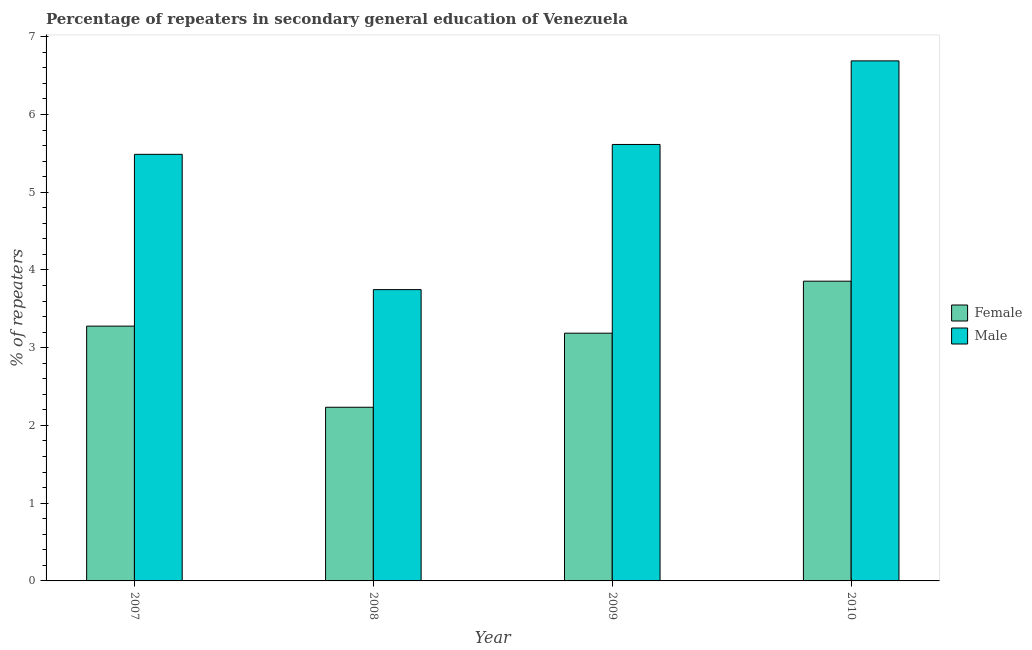How many groups of bars are there?
Offer a very short reply. 4. Are the number of bars per tick equal to the number of legend labels?
Offer a very short reply. Yes. Are the number of bars on each tick of the X-axis equal?
Your answer should be very brief. Yes. What is the label of the 2nd group of bars from the left?
Your answer should be very brief. 2008. In how many cases, is the number of bars for a given year not equal to the number of legend labels?
Keep it short and to the point. 0. What is the percentage of female repeaters in 2009?
Your answer should be very brief. 3.19. Across all years, what is the maximum percentage of male repeaters?
Ensure brevity in your answer.  6.69. Across all years, what is the minimum percentage of female repeaters?
Your answer should be compact. 2.23. In which year was the percentage of male repeaters maximum?
Your response must be concise. 2010. In which year was the percentage of female repeaters minimum?
Offer a very short reply. 2008. What is the total percentage of female repeaters in the graph?
Provide a short and direct response. 12.55. What is the difference between the percentage of female repeaters in 2009 and that in 2010?
Your answer should be compact. -0.67. What is the difference between the percentage of male repeaters in 2009 and the percentage of female repeaters in 2008?
Offer a very short reply. 1.87. What is the average percentage of male repeaters per year?
Your response must be concise. 5.38. What is the ratio of the percentage of male repeaters in 2007 to that in 2010?
Offer a very short reply. 0.82. Is the percentage of male repeaters in 2008 less than that in 2009?
Provide a short and direct response. Yes. What is the difference between the highest and the second highest percentage of female repeaters?
Give a very brief answer. 0.58. What is the difference between the highest and the lowest percentage of female repeaters?
Your response must be concise. 1.62. Is the sum of the percentage of female repeaters in 2007 and 2009 greater than the maximum percentage of male repeaters across all years?
Make the answer very short. Yes. What does the 2nd bar from the left in 2007 represents?
Give a very brief answer. Male. What does the 1st bar from the right in 2007 represents?
Offer a very short reply. Male. How many years are there in the graph?
Your answer should be compact. 4. What is the difference between two consecutive major ticks on the Y-axis?
Offer a very short reply. 1. Are the values on the major ticks of Y-axis written in scientific E-notation?
Provide a short and direct response. No. Does the graph contain grids?
Provide a succinct answer. No. Where does the legend appear in the graph?
Ensure brevity in your answer.  Center right. How many legend labels are there?
Provide a short and direct response. 2. What is the title of the graph?
Offer a terse response. Percentage of repeaters in secondary general education of Venezuela. What is the label or title of the Y-axis?
Keep it short and to the point. % of repeaters. What is the % of repeaters in Female in 2007?
Offer a terse response. 3.28. What is the % of repeaters in Male in 2007?
Your answer should be compact. 5.49. What is the % of repeaters in Female in 2008?
Offer a terse response. 2.23. What is the % of repeaters in Male in 2008?
Give a very brief answer. 3.75. What is the % of repeaters in Female in 2009?
Your answer should be compact. 3.19. What is the % of repeaters of Male in 2009?
Offer a very short reply. 5.61. What is the % of repeaters in Female in 2010?
Provide a short and direct response. 3.86. What is the % of repeaters of Male in 2010?
Your answer should be compact. 6.69. Across all years, what is the maximum % of repeaters in Female?
Offer a very short reply. 3.86. Across all years, what is the maximum % of repeaters in Male?
Offer a terse response. 6.69. Across all years, what is the minimum % of repeaters of Female?
Make the answer very short. 2.23. Across all years, what is the minimum % of repeaters in Male?
Keep it short and to the point. 3.75. What is the total % of repeaters of Female in the graph?
Your answer should be compact. 12.55. What is the total % of repeaters in Male in the graph?
Your answer should be very brief. 21.54. What is the difference between the % of repeaters in Female in 2007 and that in 2008?
Ensure brevity in your answer.  1.04. What is the difference between the % of repeaters in Male in 2007 and that in 2008?
Provide a short and direct response. 1.74. What is the difference between the % of repeaters of Female in 2007 and that in 2009?
Keep it short and to the point. 0.09. What is the difference between the % of repeaters in Male in 2007 and that in 2009?
Your answer should be very brief. -0.13. What is the difference between the % of repeaters of Female in 2007 and that in 2010?
Give a very brief answer. -0.58. What is the difference between the % of repeaters of Male in 2007 and that in 2010?
Your answer should be very brief. -1.2. What is the difference between the % of repeaters of Female in 2008 and that in 2009?
Provide a succinct answer. -0.95. What is the difference between the % of repeaters in Male in 2008 and that in 2009?
Give a very brief answer. -1.87. What is the difference between the % of repeaters of Female in 2008 and that in 2010?
Offer a very short reply. -1.62. What is the difference between the % of repeaters in Male in 2008 and that in 2010?
Keep it short and to the point. -2.94. What is the difference between the % of repeaters in Female in 2009 and that in 2010?
Provide a short and direct response. -0.67. What is the difference between the % of repeaters in Male in 2009 and that in 2010?
Offer a terse response. -1.08. What is the difference between the % of repeaters in Female in 2007 and the % of repeaters in Male in 2008?
Offer a terse response. -0.47. What is the difference between the % of repeaters of Female in 2007 and the % of repeaters of Male in 2009?
Make the answer very short. -2.34. What is the difference between the % of repeaters in Female in 2007 and the % of repeaters in Male in 2010?
Your response must be concise. -3.41. What is the difference between the % of repeaters of Female in 2008 and the % of repeaters of Male in 2009?
Your answer should be compact. -3.38. What is the difference between the % of repeaters of Female in 2008 and the % of repeaters of Male in 2010?
Keep it short and to the point. -4.46. What is the difference between the % of repeaters of Female in 2009 and the % of repeaters of Male in 2010?
Provide a succinct answer. -3.5. What is the average % of repeaters in Female per year?
Offer a very short reply. 3.14. What is the average % of repeaters in Male per year?
Your response must be concise. 5.38. In the year 2007, what is the difference between the % of repeaters in Female and % of repeaters in Male?
Your answer should be very brief. -2.21. In the year 2008, what is the difference between the % of repeaters in Female and % of repeaters in Male?
Provide a succinct answer. -1.51. In the year 2009, what is the difference between the % of repeaters in Female and % of repeaters in Male?
Offer a very short reply. -2.43. In the year 2010, what is the difference between the % of repeaters of Female and % of repeaters of Male?
Offer a terse response. -2.83. What is the ratio of the % of repeaters of Female in 2007 to that in 2008?
Provide a succinct answer. 1.47. What is the ratio of the % of repeaters of Male in 2007 to that in 2008?
Offer a very short reply. 1.46. What is the ratio of the % of repeaters in Female in 2007 to that in 2009?
Offer a terse response. 1.03. What is the ratio of the % of repeaters of Male in 2007 to that in 2009?
Ensure brevity in your answer.  0.98. What is the ratio of the % of repeaters of Female in 2007 to that in 2010?
Give a very brief answer. 0.85. What is the ratio of the % of repeaters in Male in 2007 to that in 2010?
Provide a succinct answer. 0.82. What is the ratio of the % of repeaters of Female in 2008 to that in 2009?
Your answer should be very brief. 0.7. What is the ratio of the % of repeaters of Male in 2008 to that in 2009?
Offer a very short reply. 0.67. What is the ratio of the % of repeaters in Female in 2008 to that in 2010?
Provide a succinct answer. 0.58. What is the ratio of the % of repeaters of Male in 2008 to that in 2010?
Give a very brief answer. 0.56. What is the ratio of the % of repeaters of Female in 2009 to that in 2010?
Make the answer very short. 0.83. What is the ratio of the % of repeaters in Male in 2009 to that in 2010?
Your answer should be very brief. 0.84. What is the difference between the highest and the second highest % of repeaters in Female?
Keep it short and to the point. 0.58. What is the difference between the highest and the second highest % of repeaters of Male?
Your answer should be very brief. 1.08. What is the difference between the highest and the lowest % of repeaters in Female?
Keep it short and to the point. 1.62. What is the difference between the highest and the lowest % of repeaters of Male?
Make the answer very short. 2.94. 